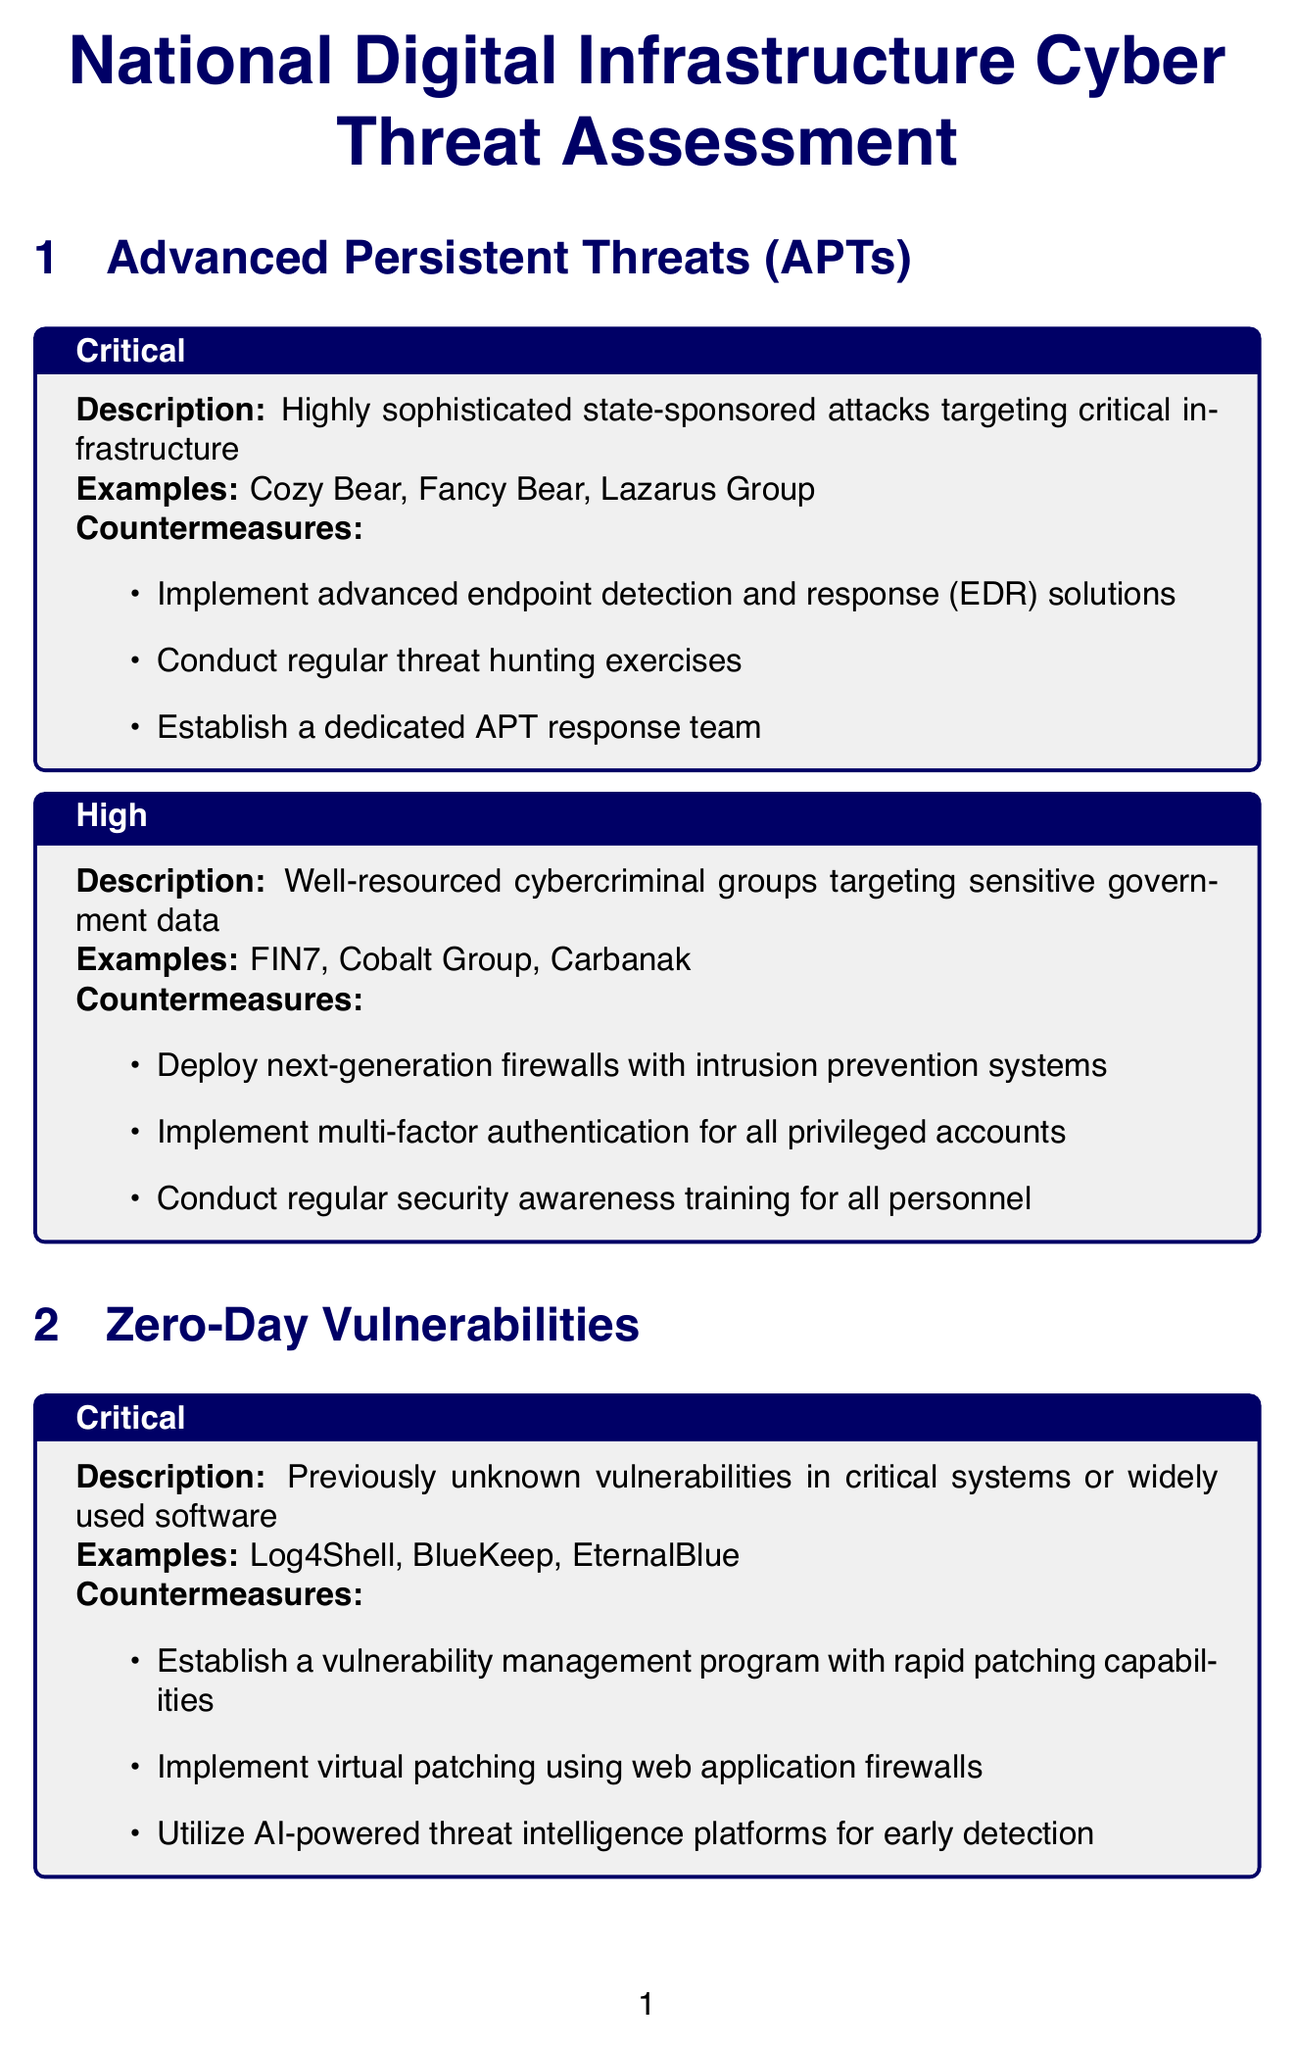what is the title of the document? The title of the document is given at the beginning, which summarizes its purpose.
Answer: National Digital Infrastructure Cyber Threat Assessment how many categories of threats are listed? The document outlines several categories of threats and their associated risks to understand the complete landscape.
Answer: 5 what is the highest risk level for Advanced Persistent Threats? The highest risk level listed for Advanced Persistent Threats is directly stated in the relevant section of the document.
Answer: Critical name one example of Zero-Day Vulnerabilities at the Critical level. The document provides specific examples for each risk level, and one can retrieve them from the relevant section.
Answer: Log4Shell what countermeasure is recommended for Insider Threats at the Medium level? The document lists specific countermeasures for each risk level within the categories, allowing straightforward retrieval for the Medium level of Insider Threats.
Answer: Conduct regular security awareness training who approved the document? The document includes an approval section detailing who has given consent to its contents, indicating the final authority on the matter.
Answer: Director of National Cybersecurity what additional recommendation suggests a constant monitoring setup? Among the various additional recommendations, one stands out by emphasizing continuous observation for security purposes.
Answer: Establish a 24/7 Security Operations Center (SOC) under which category does Ransomware Attacks fall? The categories of threats in the document are explicitly listed, allowing easy identification of the specific category related to Ransomware.
Answer: Ransomware Attacks list one countermeasure for Supply Chain Attacks at the Critical level. The specific countermeasure is provided in relation to Supply Chain Attacks, detailing actions for the critical risk level.
Answer: Implement rigorous vendor risk assessment processes 